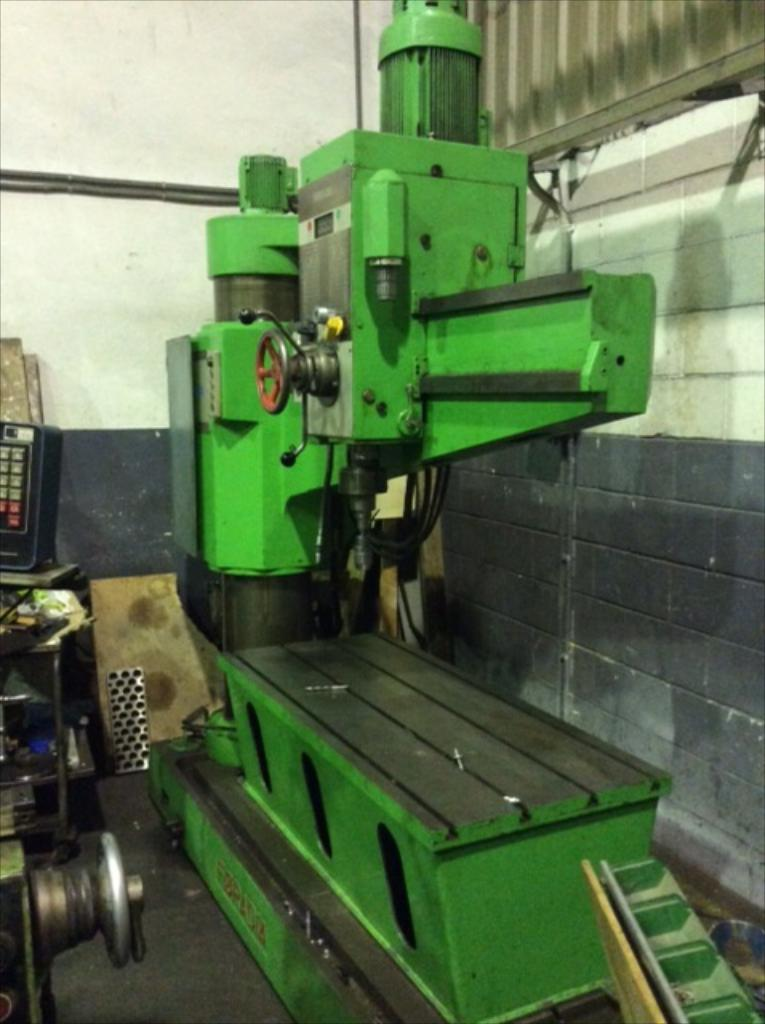What is the main object in the center of the image? There is a machine in the center of the image. What color is the machine? The machine is green in color. What can be seen on the left side of the image? There are objects on the left side of the image. What is visible in the background of the image? There is a wall in the background of the image. What colors are present on the wall? The wall is white and grey in color. What type of food is being requested by the machine in the image? There is no indication in the image that the machine is requesting food, as it is a machine and not a living being. 